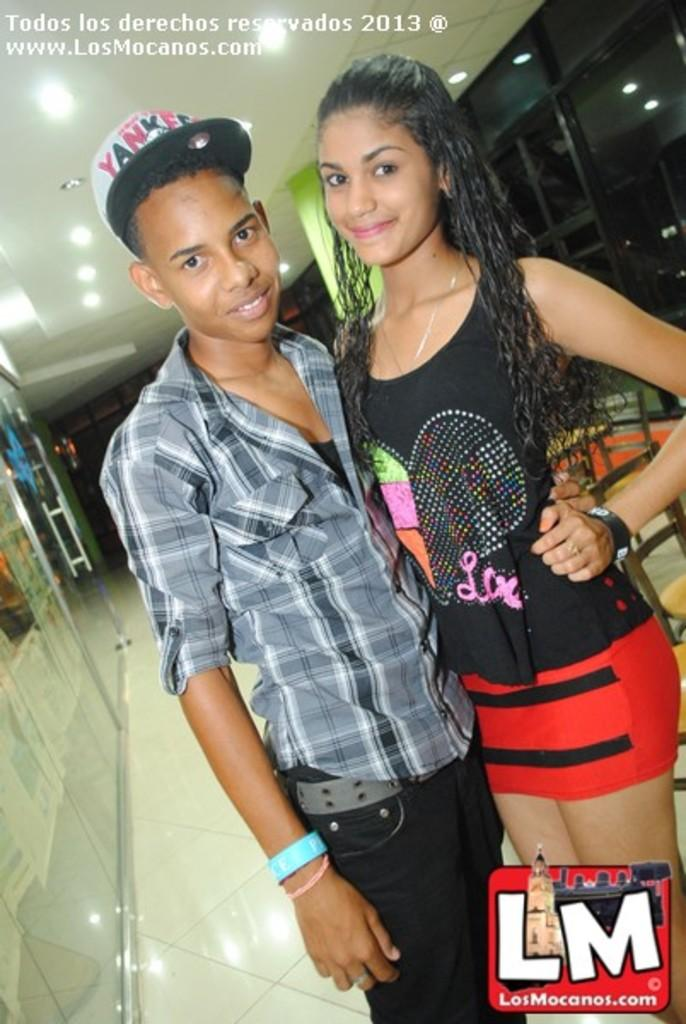How many people are in the foreground of the image? There are two people in the foreground of the image. What is located on the left side of the image? There is a door on the left side of the image. What can be seen at the top of the image? There are lights visible at the top of the image. Can you describe the person on the left side of the image? The person on the left side of the image is wearing a cap. What type of sweater is the person on the right side of the image wearing? There is no person on the right side of the image, and therefore no sweater to describe. 